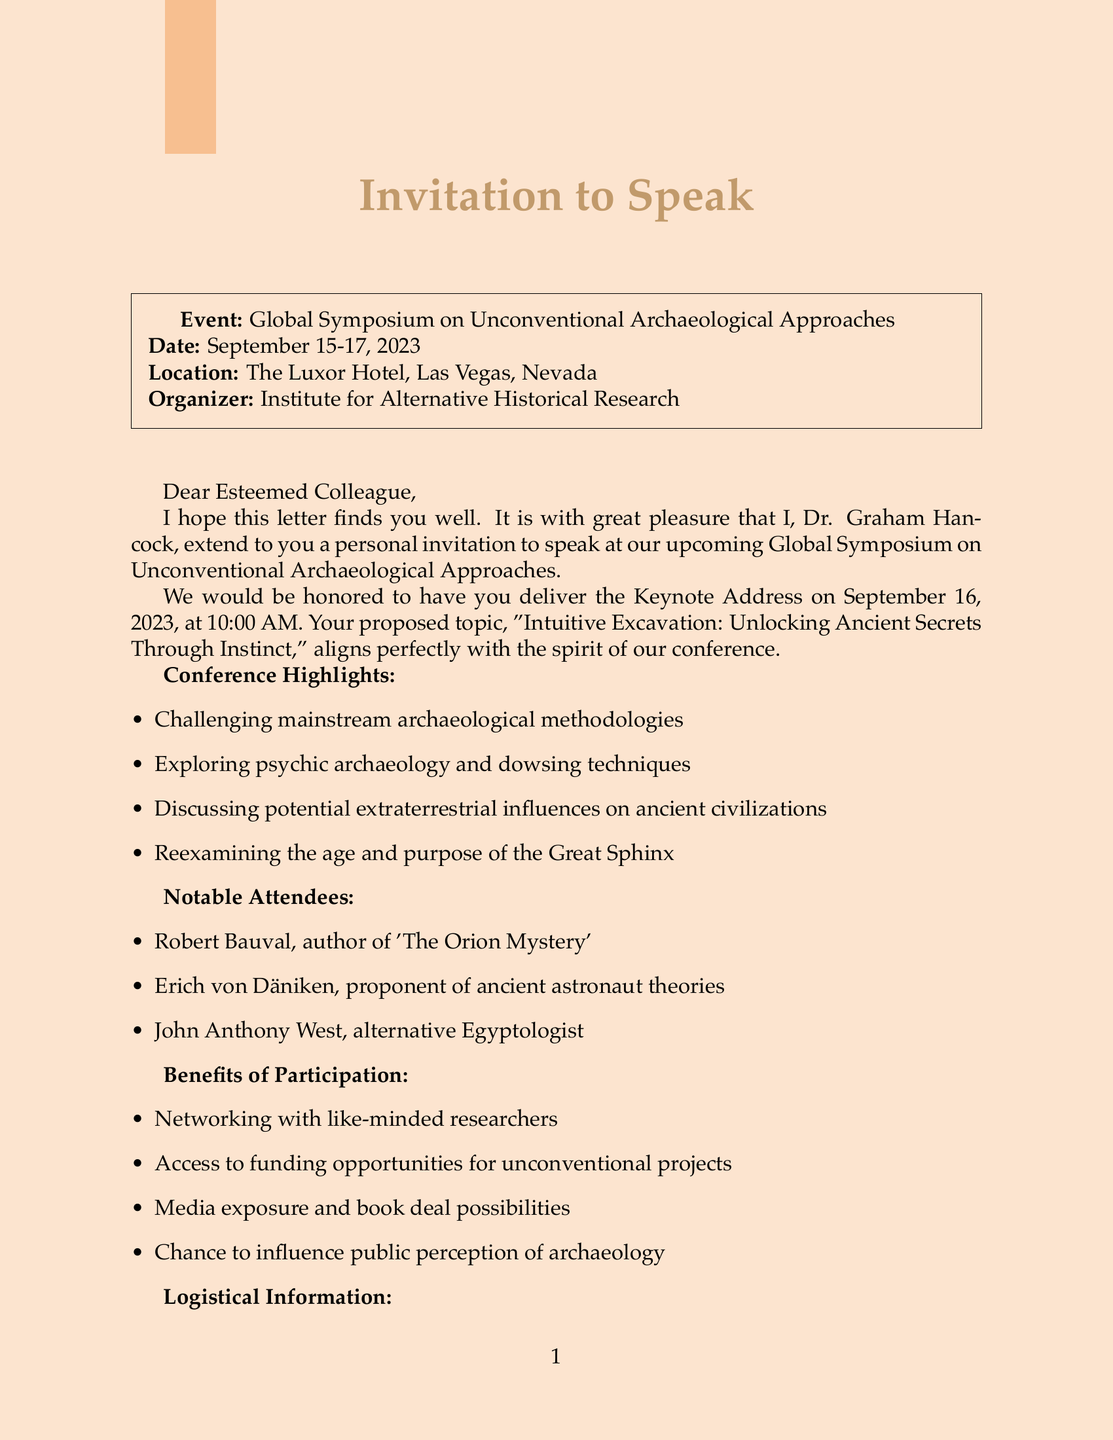What is the name of the conference? The name of the conference is mentioned as "Global Symposium on Unconventional Archaeological Approaches".
Answer: Global Symposium on Unconventional Archaeological Approaches Who invited the speaker? The invitation was extended by Dr. Graham Hancock.
Answer: Dr. Graham Hancock What is the date of the Keynote Address? The Keynote Address is scheduled for September 16, 2023.
Answer: September 16, 2023 What is the speaking fee offered? The document states that the honorarium is $5,000.
Answer: $5,000 What notable attendee is known for 'The Orion Mystery'? Robert Bauval is identified as the author of 'The Orion Mystery'.
Answer: Robert Bauval What is one potential benefit of participation in the conference? "Networking with like-minded researchers" is listed as a benefit.
Answer: Networking with like-minded researchers What is one of the controversial aspects discussed at the conference? One controversial aspect mentioned is "Discussing potential extraterrestrial influences on ancient civilizations".
Answer: Discussing potential extraterrestrial influences on ancient civilizations What is a personal relevance mentioned for attending? The opportunity to "share intuitive excavation techniques" is highlighted.
Answer: Share intuitive excavation techniques 